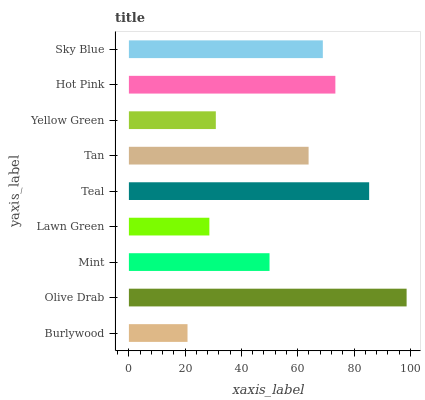Is Burlywood the minimum?
Answer yes or no. Yes. Is Olive Drab the maximum?
Answer yes or no. Yes. Is Mint the minimum?
Answer yes or no. No. Is Mint the maximum?
Answer yes or no. No. Is Olive Drab greater than Mint?
Answer yes or no. Yes. Is Mint less than Olive Drab?
Answer yes or no. Yes. Is Mint greater than Olive Drab?
Answer yes or no. No. Is Olive Drab less than Mint?
Answer yes or no. No. Is Tan the high median?
Answer yes or no. Yes. Is Tan the low median?
Answer yes or no. Yes. Is Mint the high median?
Answer yes or no. No. Is Olive Drab the low median?
Answer yes or no. No. 